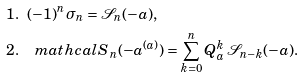Convert formula to latex. <formula><loc_0><loc_0><loc_500><loc_500>& 1 . \ \ ( - 1 ) ^ { n } \sigma _ { n } = \mathcal { S } _ { n } ( - a ) , \\ & 2 . \quad m a t h c a l { S } _ { n } ( - a ^ { ( a ) } ) = \sum _ { k = 0 } ^ { n } Q _ { a } ^ { k } \, \mathcal { S } _ { n - k } ( - a ) .</formula> 